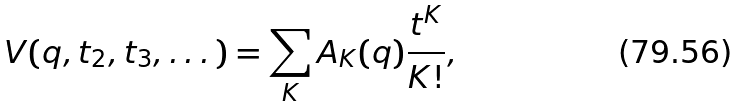<formula> <loc_0><loc_0><loc_500><loc_500>V ( q , t _ { 2 } , t _ { 3 } , \dots ) = \sum _ { K } A _ { K } ( q ) \frac { t ^ { K } } { K ! } ,</formula> 